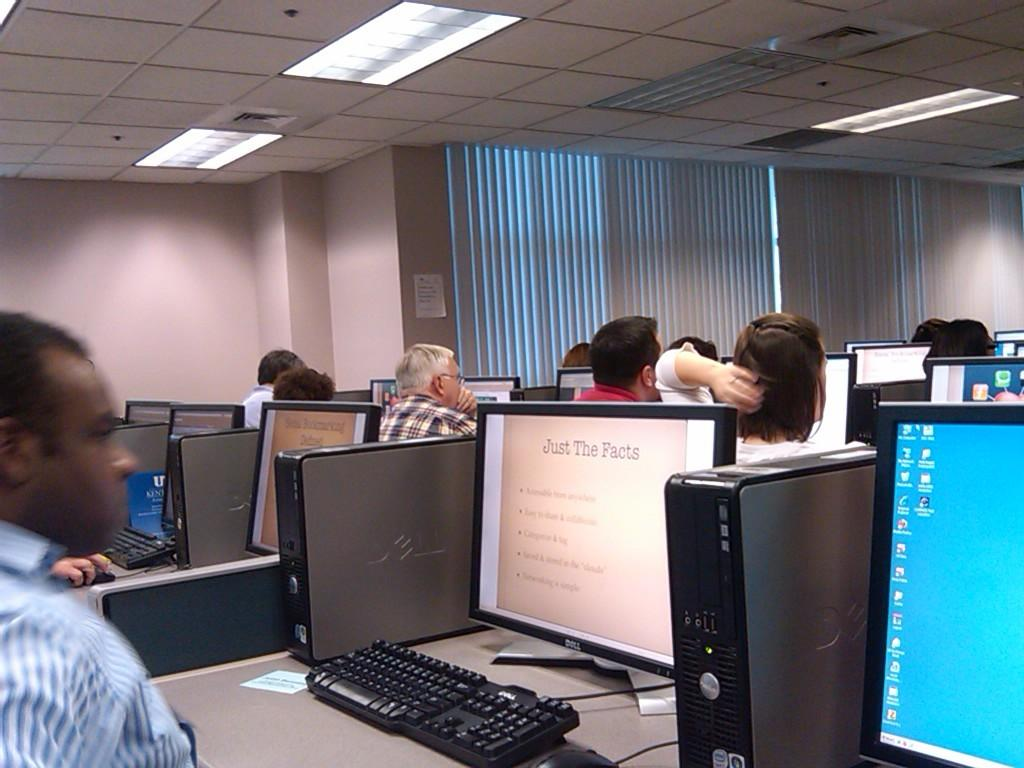How many people can be seen in the image? There are people in the image, but the exact number is not specified. What objects are on the tables in the image? Monitors, keyboards, and devices are on tables in the image. What can be seen in the background of the image? There is a wall, posts, and curtains in the background of the image. What is visible at the top of the image? Lights are visible at the top of the image. What type of pet can be seen playing music in the image? There is no pet or music present in the image. How many times have the curtains been folded in the image? The curtains are not shown being folded in the image; they are simply present in the background. 